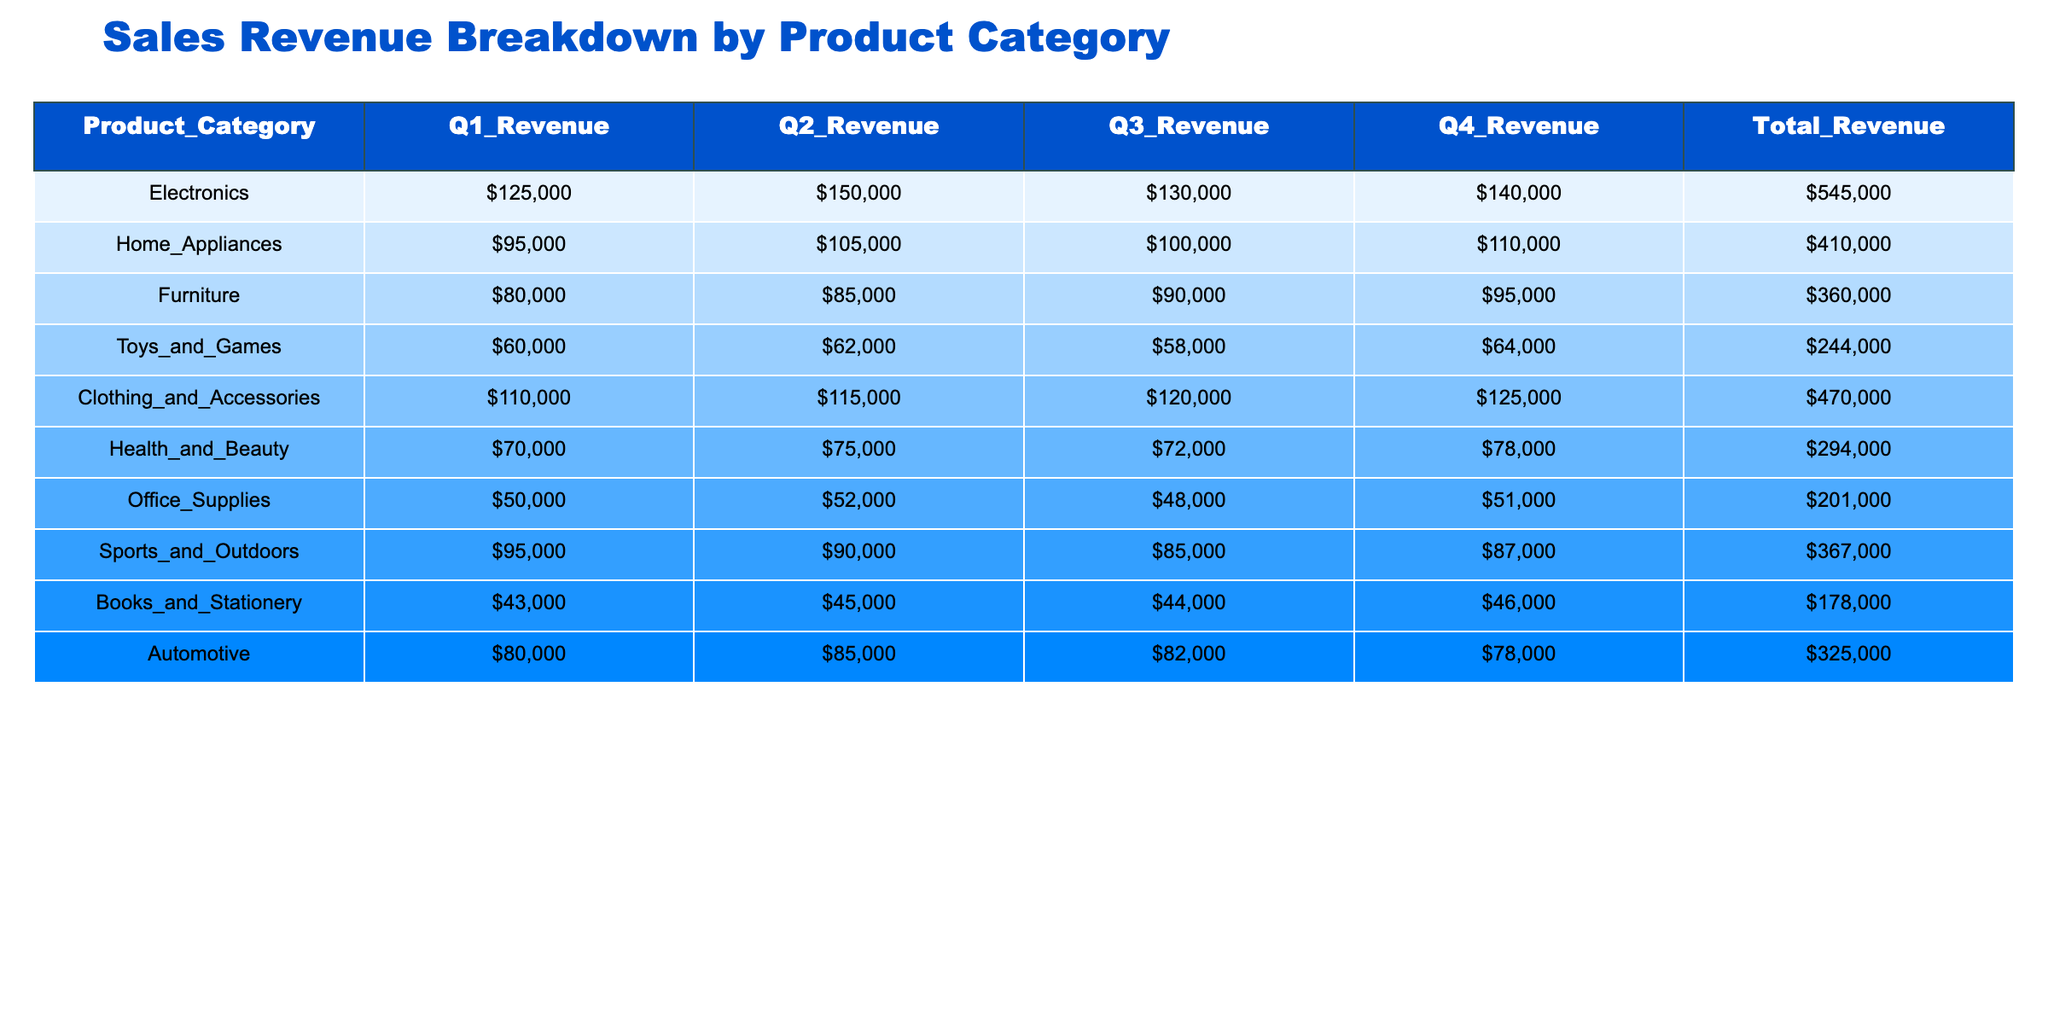What was the total revenue for Electronics? The table shows the Total Revenue for Electronics as 545,000.
Answer: 545000 What was the revenue in Q2 for Home Appliances? The table indicates the Q2 Revenue for Home Appliances is 105,000.
Answer: 105000 Which product category had the highest total revenue? By reviewing the Total Revenue column, Electronics has the highest total with 545,000.
Answer: Electronics What is the average revenue for the Clothing and Accessories category across all quarters? The total revenue for Clothing and Accessories is 470,000. Divided by 4 quarters, the average revenue is 470,000 / 4 = 117,500.
Answer: 117500 Did the Toys and Games category have any revenue above 65,000 in Q3? The Q3 revenue for Toys and Games is 58,000, which is below 65,000.
Answer: No What is the total revenue for the Sports and Outdoors category compared to Books and Stationery? Total revenue for Sports and Outdoors is 367,000 and for Books and Stationery it is 178,000. 367,000 is greater than 178,000 by 189,000.
Answer: 189000 If you sum the revenue from all quarters for Automotive, what will it be? From the table, Automotive revenues are 80,000, 85,000, 82,000, and 78,000. Summing these gives 80,000 + 85,000 + 82,000 + 78,000 = 325,000.
Answer: 325000 What is the difference in total revenue between Health and Beauty and Furniture categories? Total revenue for Health and Beauty is 294,000 and for Furniture, it is 360,000. The difference is 360,000 - 294,000 = 66,000.
Answer: 66000 What percentage of the total revenue does the Office Supplies category contribute? The Total Revenue for Office Supplies is 201,000. The overall total revenue for all categories is 545,000 + 410,000 + 360,000 + 244,000 + 470,000 + 294,000 + 201,000 + 367,000 + 178,000 + 325,000 = 3,363,000. The percentage contribution is (201,000 / 3,363,000) * 100 ≈ 5.96%.
Answer: Approximately 5.96% Which category experienced the least revenue in Q1? Reviewing Q1 revenues, Books and Stationery has the least with 43,000.
Answer: Books and Stationery 